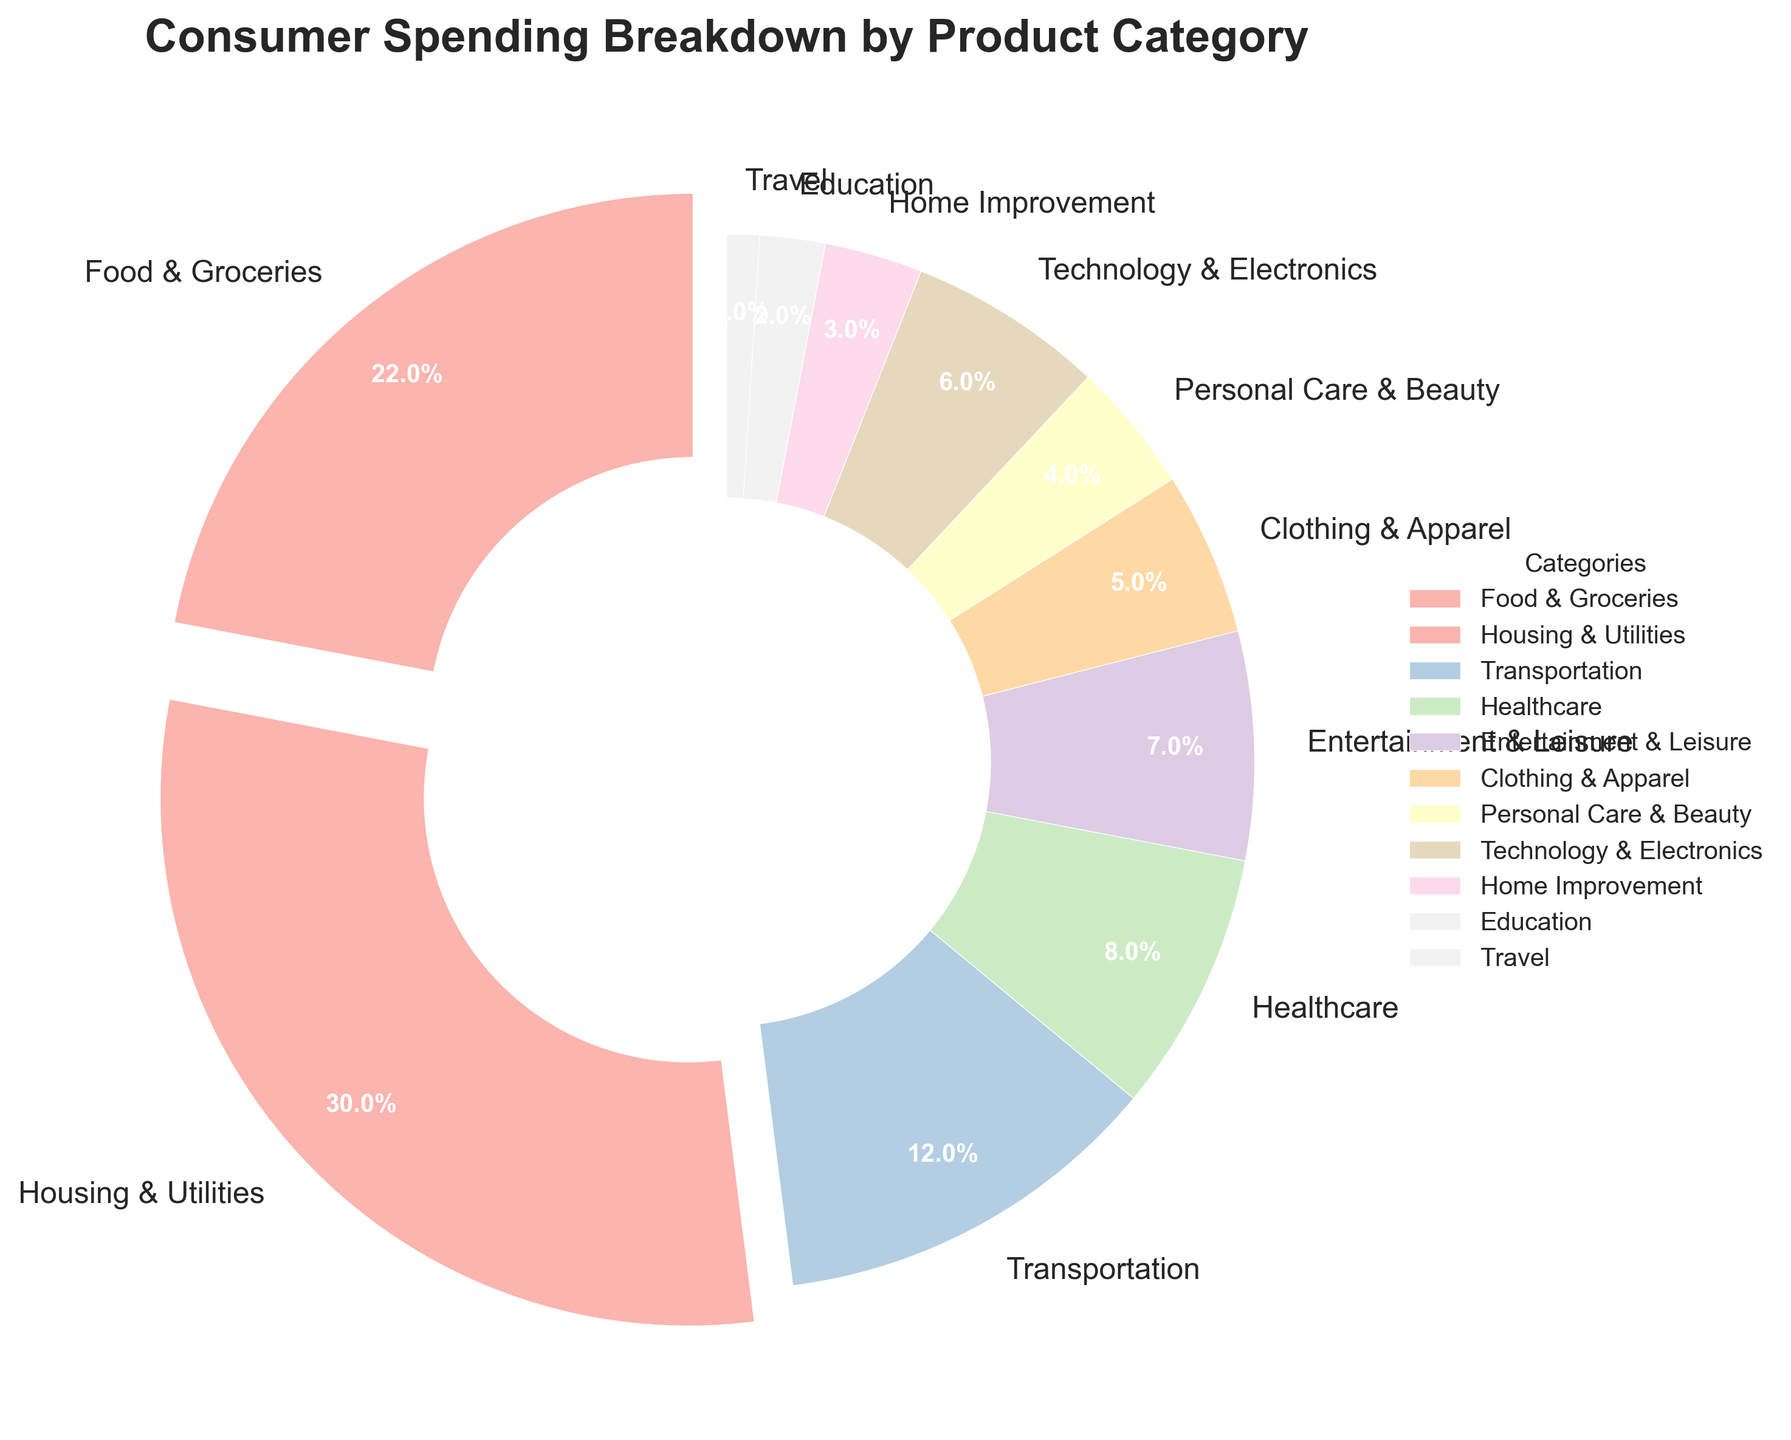Which category has the highest percentage of consumer spending? Observing the pie chart, the category with the largest slice representing the highest percentage is "Housing & Utilities."
Answer: Housing & Utilities What is the combined percentage of the categories "Food & Groceries" and "Healthcare"? From the chart, "Food & Groceries" is 22% and "Healthcare" is 8%. Adding these together results in 22% + 8% = 30%.
Answer: 30% How much more is spent on Transportation compared to Travel? From the chart, "Transportation" is 12%, and "Travel" is 1%. The difference is 12% - 1% = 11%.
Answer: 11% Which category has a lower percentage of consumer spending: Entertainment & Leisure or Technology & Electronics? Comparing the slices for "Entertainment & Leisure" and "Technology & Electronics," the percentages are 7% and 6%, respectively. So, "Technology & Electronics" is lower.
Answer: Technology & Electronics What categories fall below 5% of consumer spending each? Observing the labels and their percentages: "Personal Care & Beauty" (4%), "Home Improvement" (3%), "Education" (2%), and "Travel" (1%) all fall below 5%.
Answer: Personal Care & Beauty, Home Improvement, Education, Travel Which categories have percentages that are greater than the average percentage of all categories? There are 11 categories, so the average percentage is 100% / 11 ≈ 9.09%. The categories above this are "Food & Groceries" (22%), "Housing & Utilities" (30%), and "Transportation" (12%).
Answer: Food & Groceries, Housing & Utilities, Transportation How many categories make up more than 10% of consumer spending? Observing the pie chart, the categories above 10% are "Food & Groceries" (22%), "Housing & Utilities" (30%), and "Transportation" (12%). Counting these gives 3 categories.
Answer: 3 Which slice of the pie chart has been exploded, and why? The category "Housing & Utilities" is visually separated (exploded) from the rest because it has the highest percentage of 30%.
Answer: Housing & Utilities 